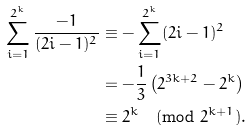<formula> <loc_0><loc_0><loc_500><loc_500>\sum _ { i = 1 } ^ { 2 ^ { k } } \frac { - 1 } { ( 2 i - 1 ) ^ { 2 } } & \equiv - \sum _ { i = 1 } ^ { 2 ^ { k } } ( 2 i - 1 ) ^ { 2 } \\ & = - \frac { 1 } { 3 } \left ( 2 ^ { 3 k + 2 } - 2 ^ { k } \right ) \\ & \equiv 2 ^ { k } \pmod { 2 ^ { k + 1 } } .</formula> 